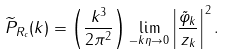Convert formula to latex. <formula><loc_0><loc_0><loc_500><loc_500>\widetilde { P } _ { R _ { c } } ( k ) = \left ( \frac { k ^ { 3 } } { 2 \pi ^ { 2 } } \right ) \lim _ { - k \eta \rightarrow 0 } \left | \frac { \tilde { \varphi } _ { k } } { z _ { k } } \right | ^ { 2 } .</formula> 